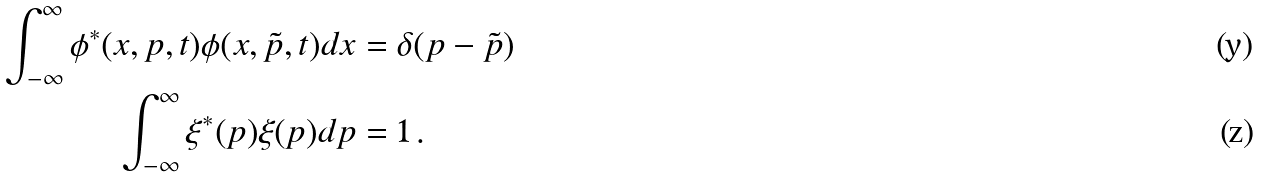Convert formula to latex. <formula><loc_0><loc_0><loc_500><loc_500>\int ^ { \infty } _ { - \infty } \phi ^ { * } ( x , p , t ) \phi ( x , \tilde { p } , t ) d x & = \delta ( p - \tilde { p } ) \\ \int ^ { \infty } _ { - \infty } \xi ^ { * } ( p ) \xi ( p ) d p & = 1 \, .</formula> 